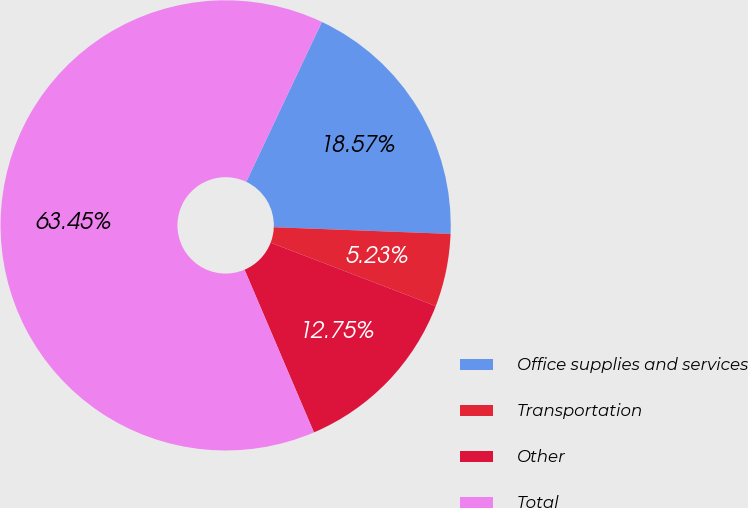Convert chart to OTSL. <chart><loc_0><loc_0><loc_500><loc_500><pie_chart><fcel>Office supplies and services<fcel>Transportation<fcel>Other<fcel>Total<nl><fcel>18.57%<fcel>5.23%<fcel>12.75%<fcel>63.44%<nl></chart> 